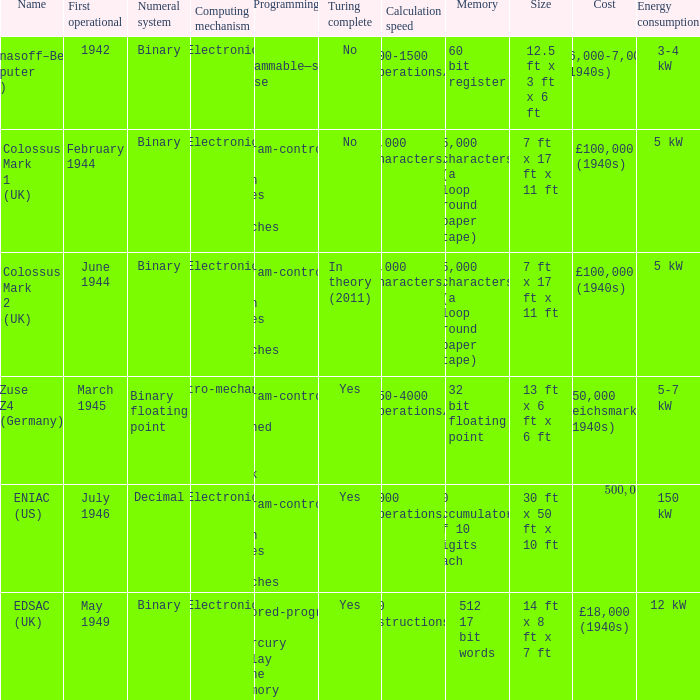Can you give me this table as a dict? {'header': ['Name', 'First operational', 'Numeral system', 'Computing mechanism', 'Programming', 'Turing complete', 'Calculation speed', 'Memory', 'Size', 'Cost', 'Energy consumption'], 'rows': [['Atanasoff–Berry Computer (US)', '1942', 'Binary', 'Electronic', 'Not programmable—single purpose', 'No', '100-1500 operations/s', '60 bit register', '12.5 ft x 3 ft x 6 ft', '$6,000-7,000 (1940s)', '3-4 kW'], ['Colossus Mark 1 (UK)', 'February 1944', 'Binary', 'Electronic', 'Program-controlled by patch cables and switches', 'No', '5,000 characters/s', '5,000 characters (a loop round paper tape)', '7 ft x 17 ft x 11 ft', '£100,000 (1940s)', '5 kW'], ['Colossus Mark 2 (UK)', 'June 1944', 'Binary', 'Electronic', 'Program-controlled by patch cables and switches', 'In theory (2011)', '5,000 characters/s', '5,000 characters (a loop round paper tape)', '7 ft x 17 ft x 11 ft', '£100,000 (1940s)', '5 kW'], ['Zuse Z4 (Germany)', 'March 1945', 'Binary floating point', 'Electro-mechanical', 'Program-controlled by punched 35mm film stock', 'Yes', '250-4000 operations/s', '32 bit floating point', '13 ft x 6 ft x 6 ft', '250,000 Reichsmarks (1940s)', '5-7 kW'], ['ENIAC (US)', 'July 1946', 'Decimal', 'Electronic', 'Program-controlled by patch cables and switches', 'Yes', '5000 operations/s', '20 accumulators of 10 digits each', '30 ft x 50 ft x 10 ft', '$500,000- $1,000,000 (1940s)', '150 kW'], ['EDSAC (UK)', 'May 1949', 'Binary', 'Electronic', 'Stored-program in mercury delay line memory', 'Yes', '700 instructions/s', '512 17 bit words', '14 ft x 8 ft x 7 ft', '£18,000 (1940s)', '12 kW']]} What's the computing mechanbeingm with first operational being february 1944 Electronic. 